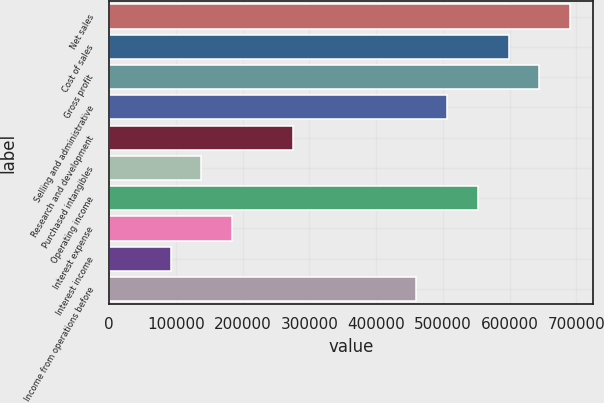<chart> <loc_0><loc_0><loc_500><loc_500><bar_chart><fcel>Net sales<fcel>Cost of sales<fcel>Gross profit<fcel>Selling and administrative<fcel>Research and development<fcel>Purchased intangibles<fcel>Operating income<fcel>Interest expense<fcel>Interest income<fcel>Income from operations before<nl><fcel>690605<fcel>598525<fcel>644565<fcel>506444<fcel>276243<fcel>138122<fcel>552485<fcel>184162<fcel>92081.7<fcel>460404<nl></chart> 